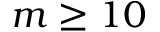<formula> <loc_0><loc_0><loc_500><loc_500>m \geq 1 0</formula> 